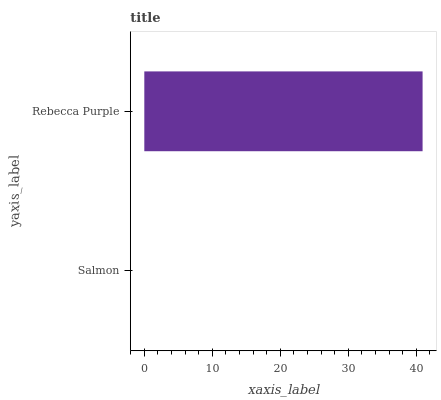Is Salmon the minimum?
Answer yes or no. Yes. Is Rebecca Purple the maximum?
Answer yes or no. Yes. Is Rebecca Purple the minimum?
Answer yes or no. No. Is Rebecca Purple greater than Salmon?
Answer yes or no. Yes. Is Salmon less than Rebecca Purple?
Answer yes or no. Yes. Is Salmon greater than Rebecca Purple?
Answer yes or no. No. Is Rebecca Purple less than Salmon?
Answer yes or no. No. Is Rebecca Purple the high median?
Answer yes or no. Yes. Is Salmon the low median?
Answer yes or no. Yes. Is Salmon the high median?
Answer yes or no. No. Is Rebecca Purple the low median?
Answer yes or no. No. 